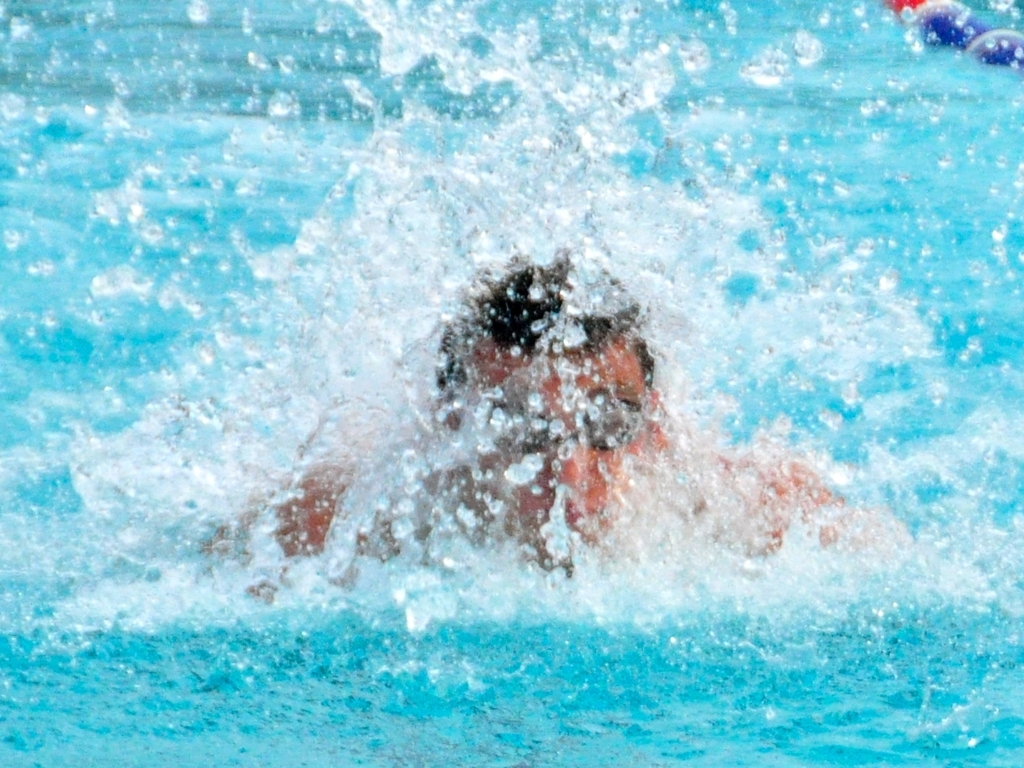Does the photo capture the moment when the athlete splashes in the water?
 Yes 